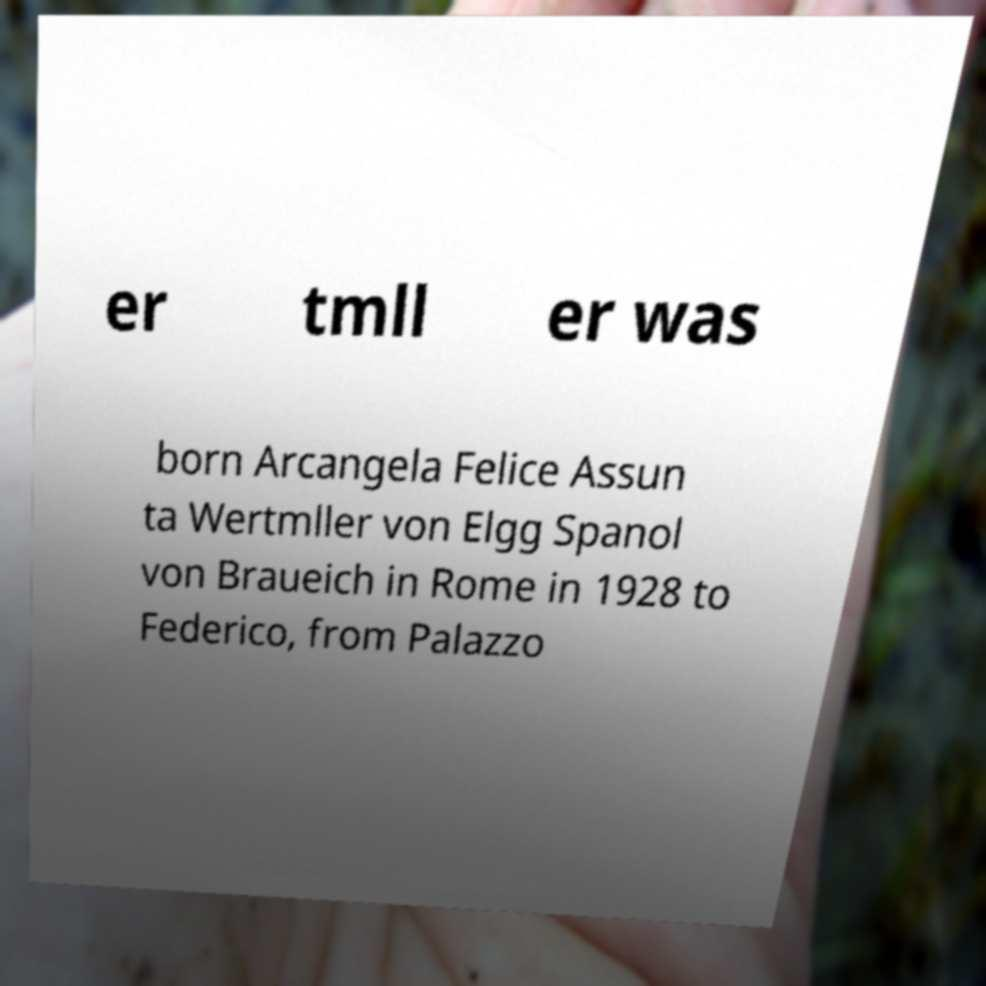Can you accurately transcribe the text from the provided image for me? er tmll er was born Arcangela Felice Assun ta Wertmller von Elgg Spanol von Braueich in Rome in 1928 to Federico, from Palazzo 